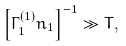<formula> <loc_0><loc_0><loc_500><loc_500>\left [ \Gamma _ { 1 } ^ { ( 1 ) } n _ { 1 } \right ] ^ { - 1 } \gg T ,</formula> 